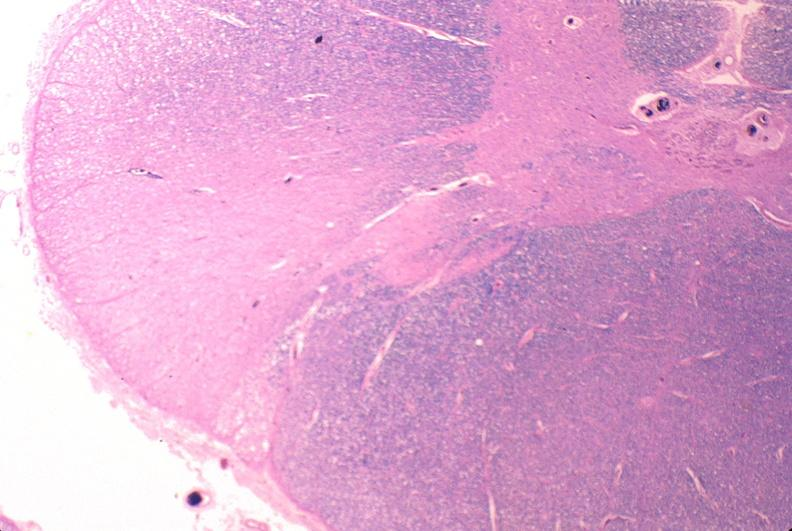does this image show spinal cord injury due to vertebral column trauma, demyelination?
Answer the question using a single word or phrase. Yes 